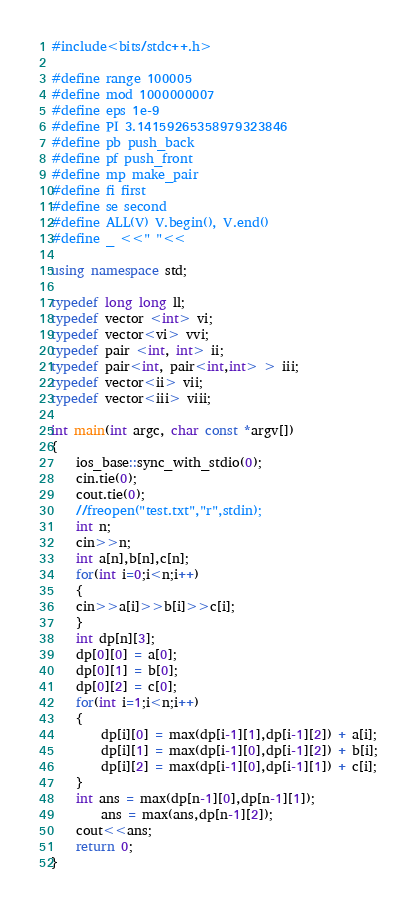Convert code to text. <code><loc_0><loc_0><loc_500><loc_500><_C++_>#include<bits/stdc++.h>

#define range 100005
#define mod 1000000007
#define eps 1e-9
#define PI 3.14159265358979323846
#define pb push_back
#define pf push_front
#define mp make_pair
#define fi first
#define se second
#define ALL(V) V.begin(), V.end()
#define _ <<" "<<

using namespace std;

typedef long long ll;
typedef vector <int> vi;
typedef vector<vi> vvi;
typedef pair <int, int> ii;
typedef pair<int, pair<int,int> > iii;
typedef vector<ii> vii;
typedef vector<iii> viii;

int main(int argc, char const *argv[])
{
	ios_base::sync_with_stdio(0);
	cin.tie(0);
	cout.tie(0);
	//freopen("test.txt","r",stdin);
	int n;
	cin>>n;
	int a[n],b[n],c[n];
	for(int i=0;i<n;i++)
	{
	cin>>a[i]>>b[i]>>c[i];	
	}
	int dp[n][3];
	dp[0][0] = a[0];
	dp[0][1] = b[0];
	dp[0][2] = c[0];
	for(int i=1;i<n;i++)
	{
	   	dp[i][0] = max(dp[i-1][1],dp[i-1][2]) + a[i];
	   	dp[i][1] = max(dp[i-1][0],dp[i-1][2]) + b[i];
	   	dp[i][2] = max(dp[i-1][0],dp[i-1][1]) + c[i];
	}
	int ans = max(dp[n-1][0],dp[n-1][1]);
		ans = max(ans,dp[n-1][2]);
	cout<<ans;
	return 0;
}</code> 